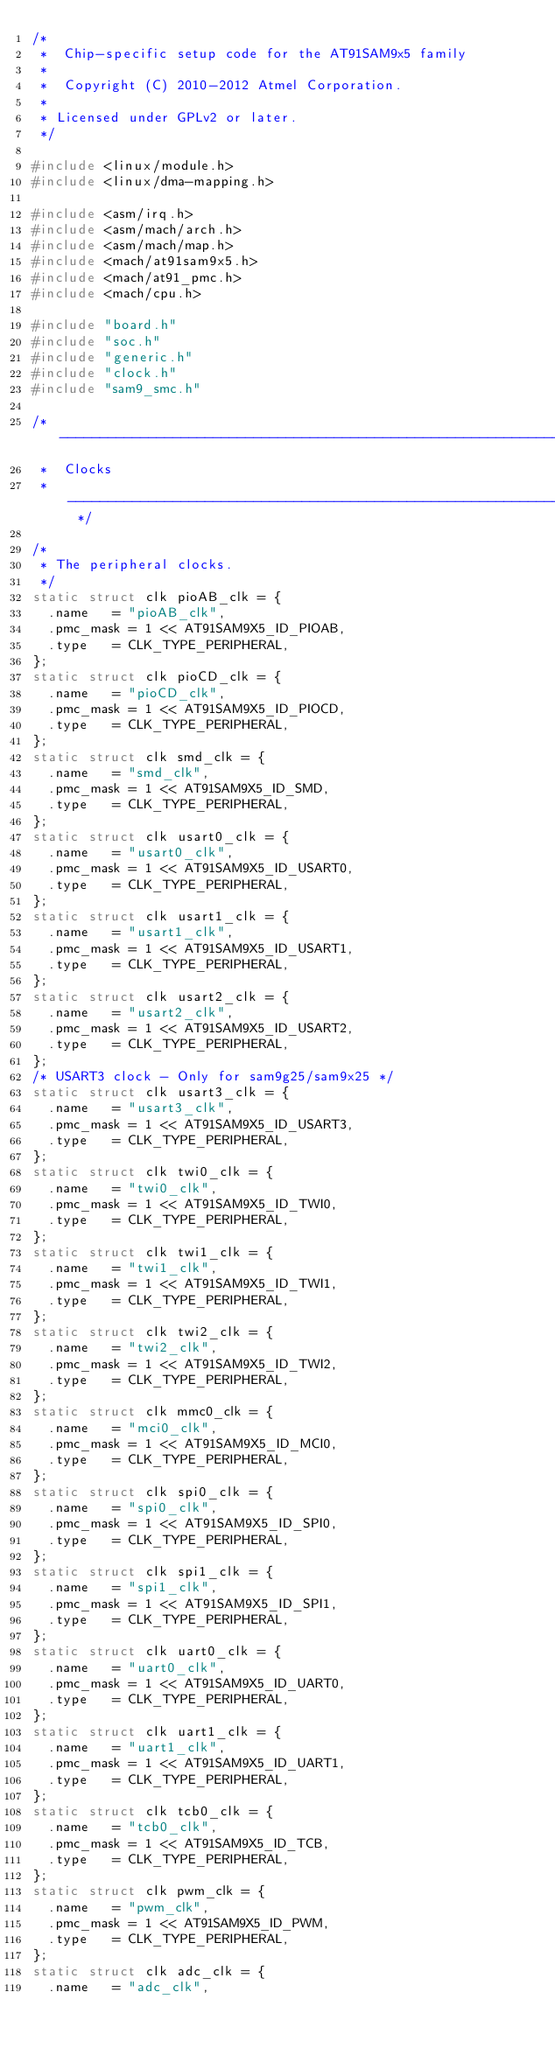<code> <loc_0><loc_0><loc_500><loc_500><_C_>/*
 *  Chip-specific setup code for the AT91SAM9x5 family
 *
 *  Copyright (C) 2010-2012 Atmel Corporation.
 *
 * Licensed under GPLv2 or later.
 */

#include <linux/module.h>
#include <linux/dma-mapping.h>

#include <asm/irq.h>
#include <asm/mach/arch.h>
#include <asm/mach/map.h>
#include <mach/at91sam9x5.h>
#include <mach/at91_pmc.h>
#include <mach/cpu.h>

#include "board.h"
#include "soc.h"
#include "generic.h"
#include "clock.h"
#include "sam9_smc.h"

/* --------------------------------------------------------------------
 *  Clocks
 * -------------------------------------------------------------------- */

/*
 * The peripheral clocks.
 */
static struct clk pioAB_clk = {
	.name		= "pioAB_clk",
	.pmc_mask	= 1 << AT91SAM9X5_ID_PIOAB,
	.type		= CLK_TYPE_PERIPHERAL,
};
static struct clk pioCD_clk = {
	.name		= "pioCD_clk",
	.pmc_mask	= 1 << AT91SAM9X5_ID_PIOCD,
	.type		= CLK_TYPE_PERIPHERAL,
};
static struct clk smd_clk = {
	.name		= "smd_clk",
	.pmc_mask	= 1 << AT91SAM9X5_ID_SMD,
	.type		= CLK_TYPE_PERIPHERAL,
};
static struct clk usart0_clk = {
	.name		= "usart0_clk",
	.pmc_mask	= 1 << AT91SAM9X5_ID_USART0,
	.type		= CLK_TYPE_PERIPHERAL,
};
static struct clk usart1_clk = {
	.name		= "usart1_clk",
	.pmc_mask	= 1 << AT91SAM9X5_ID_USART1,
	.type		= CLK_TYPE_PERIPHERAL,
};
static struct clk usart2_clk = {
	.name		= "usart2_clk",
	.pmc_mask	= 1 << AT91SAM9X5_ID_USART2,
	.type		= CLK_TYPE_PERIPHERAL,
};
/* USART3 clock - Only for sam9g25/sam9x25 */
static struct clk usart3_clk = {
	.name		= "usart3_clk",
	.pmc_mask	= 1 << AT91SAM9X5_ID_USART3,
	.type		= CLK_TYPE_PERIPHERAL,
};
static struct clk twi0_clk = {
	.name		= "twi0_clk",
	.pmc_mask	= 1 << AT91SAM9X5_ID_TWI0,
	.type		= CLK_TYPE_PERIPHERAL,
};
static struct clk twi1_clk = {
	.name		= "twi1_clk",
	.pmc_mask	= 1 << AT91SAM9X5_ID_TWI1,
	.type		= CLK_TYPE_PERIPHERAL,
};
static struct clk twi2_clk = {
	.name		= "twi2_clk",
	.pmc_mask	= 1 << AT91SAM9X5_ID_TWI2,
	.type		= CLK_TYPE_PERIPHERAL,
};
static struct clk mmc0_clk = {
	.name		= "mci0_clk",
	.pmc_mask	= 1 << AT91SAM9X5_ID_MCI0,
	.type		= CLK_TYPE_PERIPHERAL,
};
static struct clk spi0_clk = {
	.name		= "spi0_clk",
	.pmc_mask	= 1 << AT91SAM9X5_ID_SPI0,
	.type		= CLK_TYPE_PERIPHERAL,
};
static struct clk spi1_clk = {
	.name		= "spi1_clk",
	.pmc_mask	= 1 << AT91SAM9X5_ID_SPI1,
	.type		= CLK_TYPE_PERIPHERAL,
};
static struct clk uart0_clk = {
	.name		= "uart0_clk",
	.pmc_mask	= 1 << AT91SAM9X5_ID_UART0,
	.type		= CLK_TYPE_PERIPHERAL,
};
static struct clk uart1_clk = {
	.name		= "uart1_clk",
	.pmc_mask	= 1 << AT91SAM9X5_ID_UART1,
	.type		= CLK_TYPE_PERIPHERAL,
};
static struct clk tcb0_clk = {
	.name		= "tcb0_clk",
	.pmc_mask	= 1 << AT91SAM9X5_ID_TCB,
	.type		= CLK_TYPE_PERIPHERAL,
};
static struct clk pwm_clk = {
	.name		= "pwm_clk",
	.pmc_mask	= 1 << AT91SAM9X5_ID_PWM,
	.type		= CLK_TYPE_PERIPHERAL,
};
static struct clk adc_clk = {
	.name		= "adc_clk",</code> 